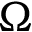Convert formula to latex. <formula><loc_0><loc_0><loc_500><loc_500>\Omega</formula> 